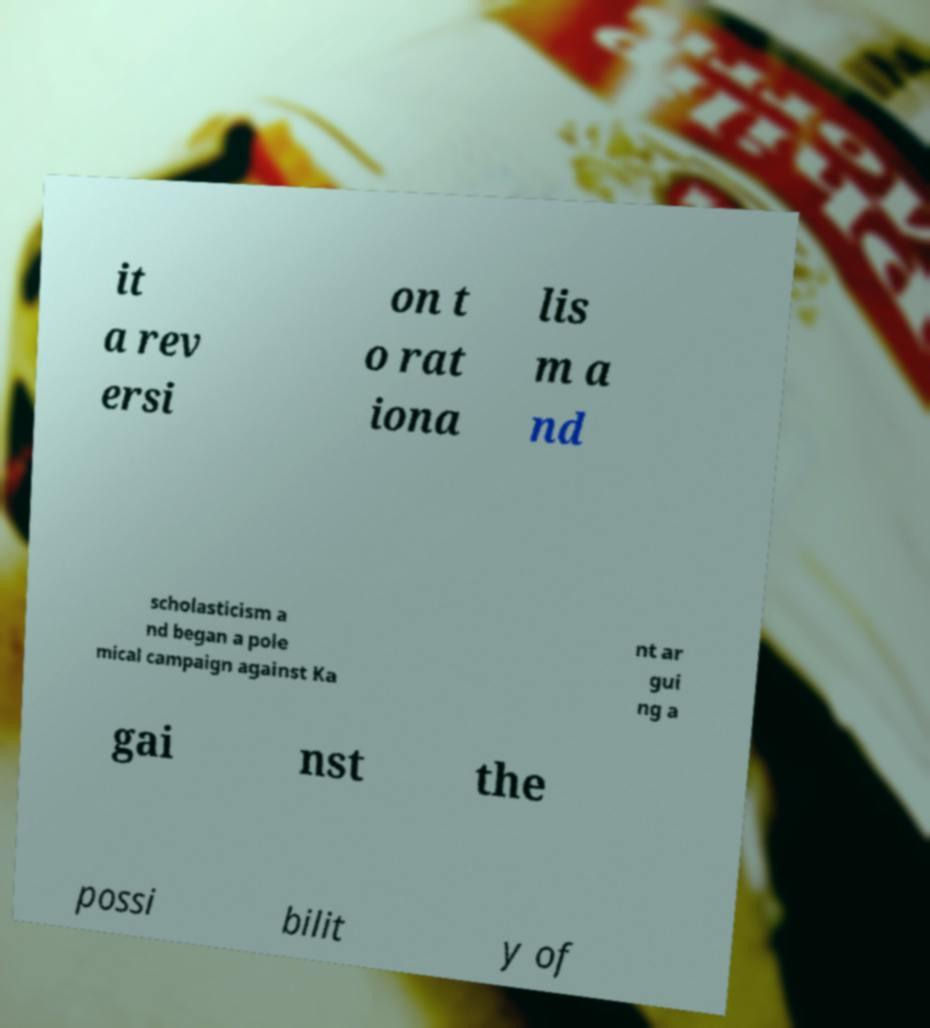What messages or text are displayed in this image? I need them in a readable, typed format. it a rev ersi on t o rat iona lis m a nd scholasticism a nd began a pole mical campaign against Ka nt ar gui ng a gai nst the possi bilit y of 